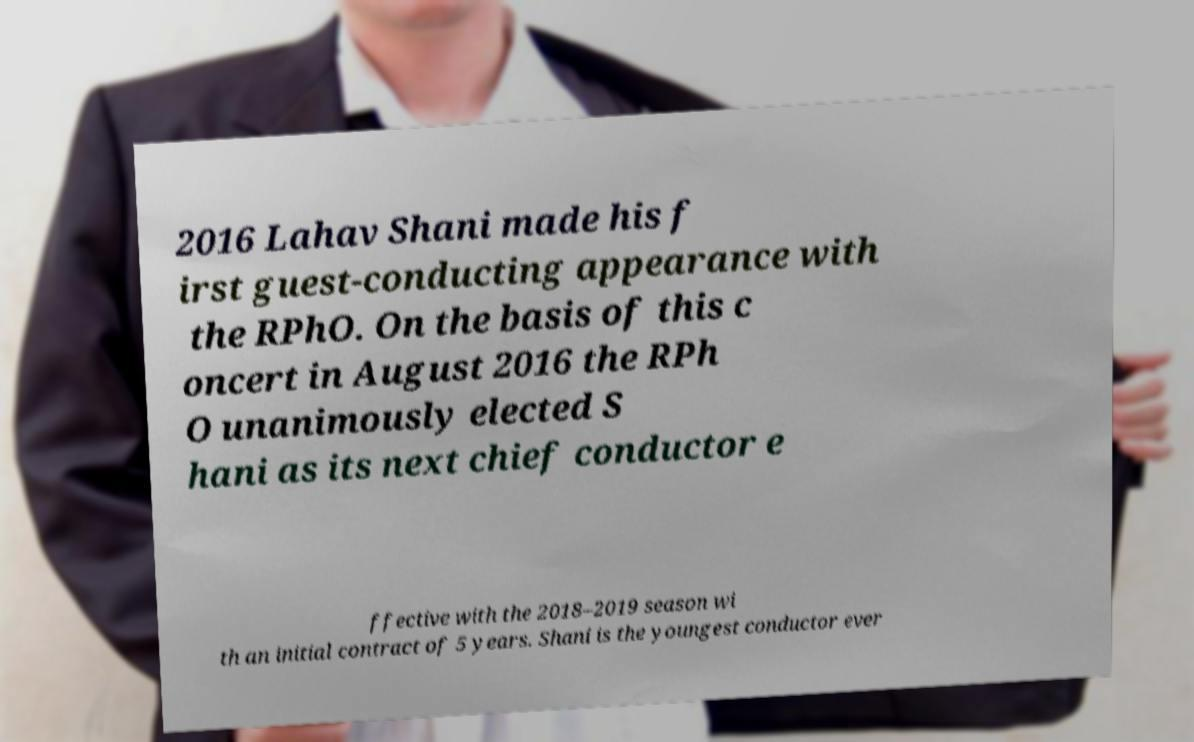What messages or text are displayed in this image? I need them in a readable, typed format. 2016 Lahav Shani made his f irst guest-conducting appearance with the RPhO. On the basis of this c oncert in August 2016 the RPh O unanimously elected S hani as its next chief conductor e ffective with the 2018–2019 season wi th an initial contract of 5 years. Shani is the youngest conductor ever 